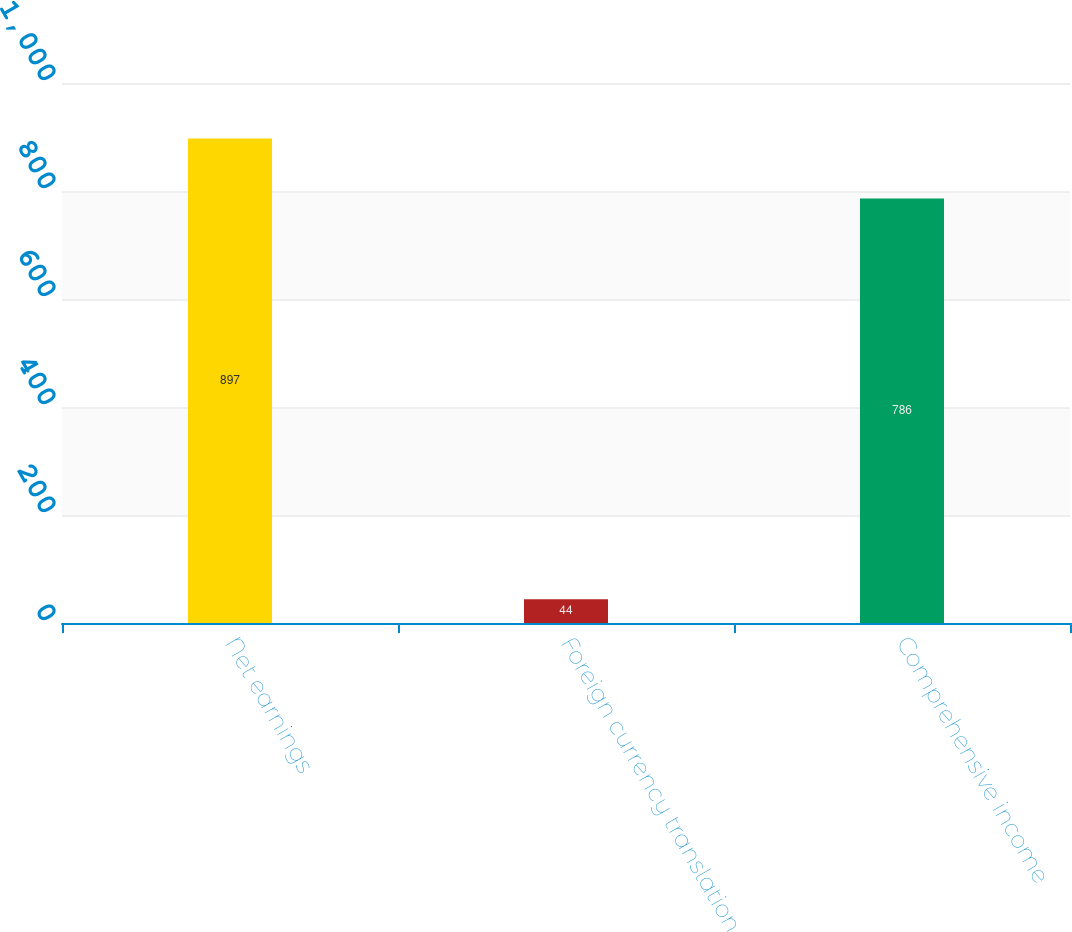<chart> <loc_0><loc_0><loc_500><loc_500><bar_chart><fcel>Net earnings<fcel>Foreign currency translation<fcel>Comprehensive income<nl><fcel>897<fcel>44<fcel>786<nl></chart> 